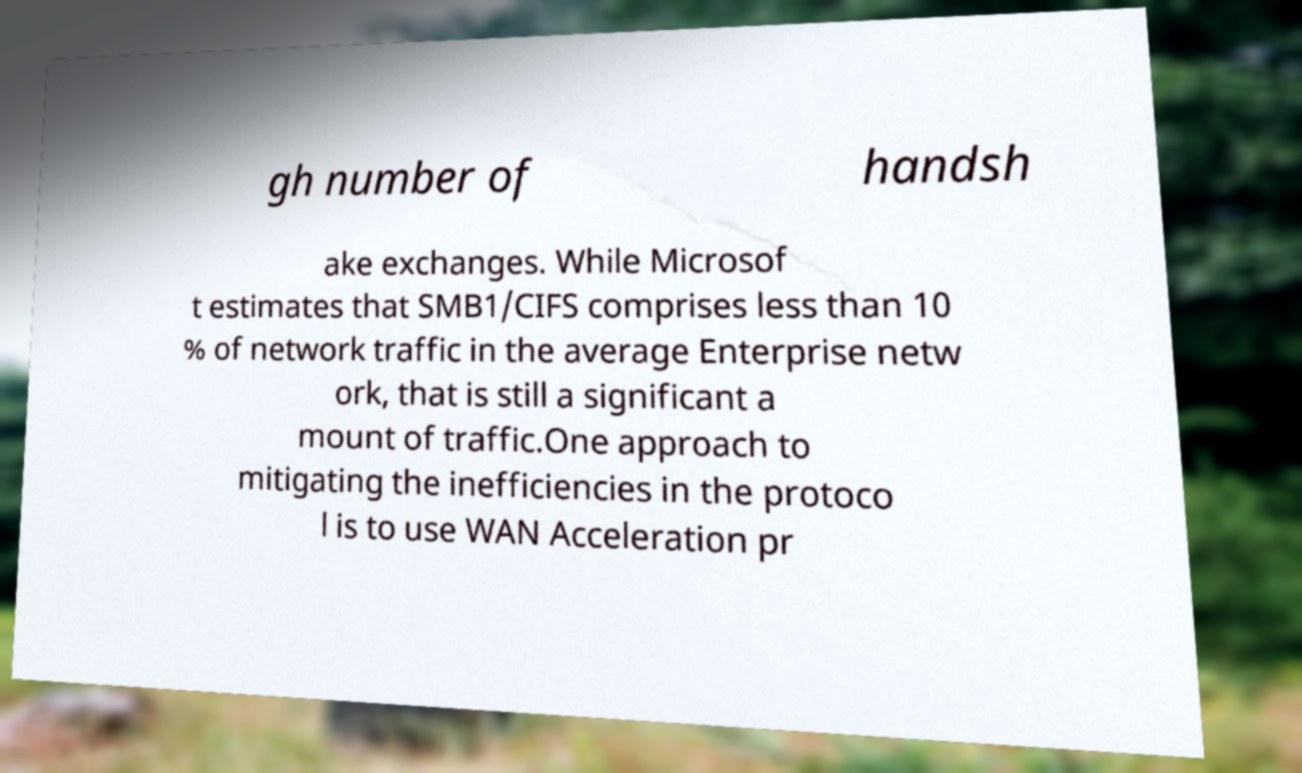What messages or text are displayed in this image? I need them in a readable, typed format. gh number of handsh ake exchanges. While Microsof t estimates that SMB1/CIFS comprises less than 10 % of network traffic in the average Enterprise netw ork, that is still a significant a mount of traffic.One approach to mitigating the inefficiencies in the protoco l is to use WAN Acceleration pr 